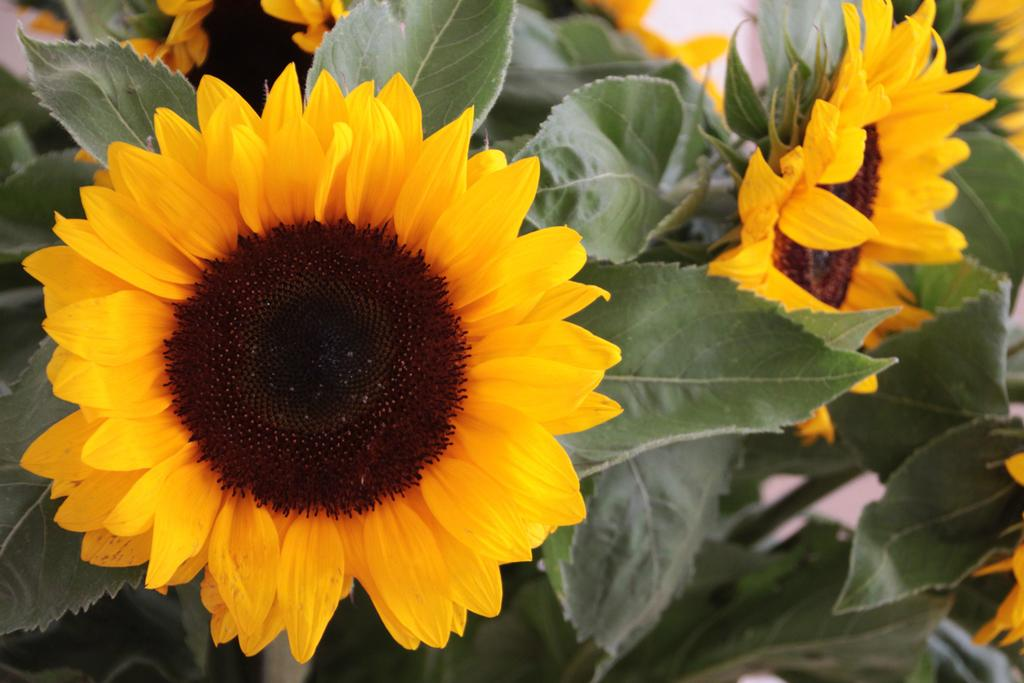What type of flowers are in the image? There are sunflowers in the image. What else can be seen in the image besides the sunflowers? There are leaves in the image. What is the arithmetic equation that can be solved using the sunflowers in the image? There is no arithmetic equation present in the image, as it features sunflowers and leaves. 